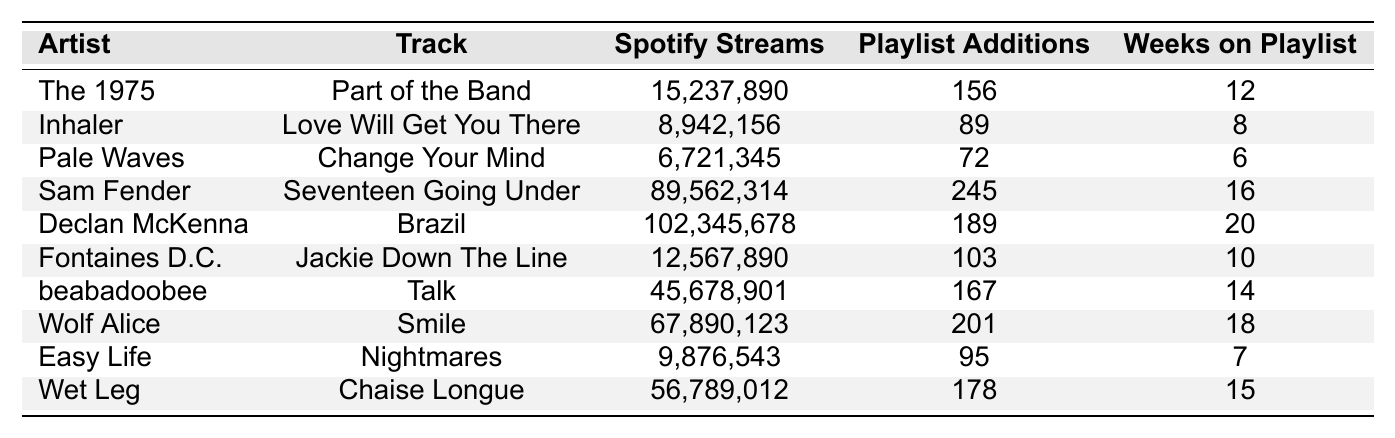What is the track with the highest Spotify streams? By reviewing the Spotify streams in the table, "Brazil" by Declan McKenna shows the highest streams with a total of 102,345,678.
Answer: Brazil Which artist has the most playlist additions? Looking at the playlist additions, "Seventeen Going Under" by Sam Fender has the highest number with 245 additions.
Answer: Sam Fender What is the average number of weeks tracks have been on the playlist? The total weeks on the playlist is (12 + 8 + 6 + 16 + 20 + 10 + 14 + 18 + 7 + 15) = 126. Dividing by 10 (the number of tracks), the average is 126/10 = 12.6 weeks.
Answer: 12.6 weeks How many tracks have more than 20 weeks on the playlist? By examining the "Weeks on Playlist" column, only "Brazil" and "Declan McKenna" have more than 20 weeks (20 weeks), totaling 2 tracks.
Answer: 1 track Which track has the least number of Spotify streams? Considering the Spotify streams data, "Change Your Mind" by Pale Waves has the least with 6,721,345 streams.
Answer: Change Your Mind Is beabadoobee's "Talk" among the top three tracks with the most Spotify streams? Comparing the Spotify streams, "Talk" with 45,678,901 is indeed among the top three as others, "Brazil," "Seventeen Going Under," and "Smile" have more.
Answer: Yes What is the difference in Spotify streams between the highest and lowest tracks? The highest is "Brazil" (102,345,678) and the lowest is "Change Your Mind" (6,721,345). The difference is 102,345,678 - 6,721,345 = 95,624,333.
Answer: 95,624,333 Which artist has more playlist additions, The 1975 or Wet Leg? "Part of the Band" by The 1975 has 156 additions and "Chaise Longue" by Wet Leg has 178. Wet Leg has more additions.
Answer: Wet Leg What is the median number of Spotify streams for the tracks listed? The Spotify streams in order: [6,721,345, 8,942,156, 12,567,890, 15,237,890, 45,678,901, 56,789,012, 67,890,123, 89,562,314, 102,345,678]. The median (middle value) is between the 5th and 6th values: (45,678,901 + 56,789,012) / 2 = 51,233,956.5.
Answer: 51,233,956.5 How many total playlist additions do all tracks combined have? Summing the playlist additions gives (156 + 89 + 72 + 245 + 189 + 103 + 167 + 201 + 95 + 178) = 1,255 total playlist additions.
Answer: 1,255 